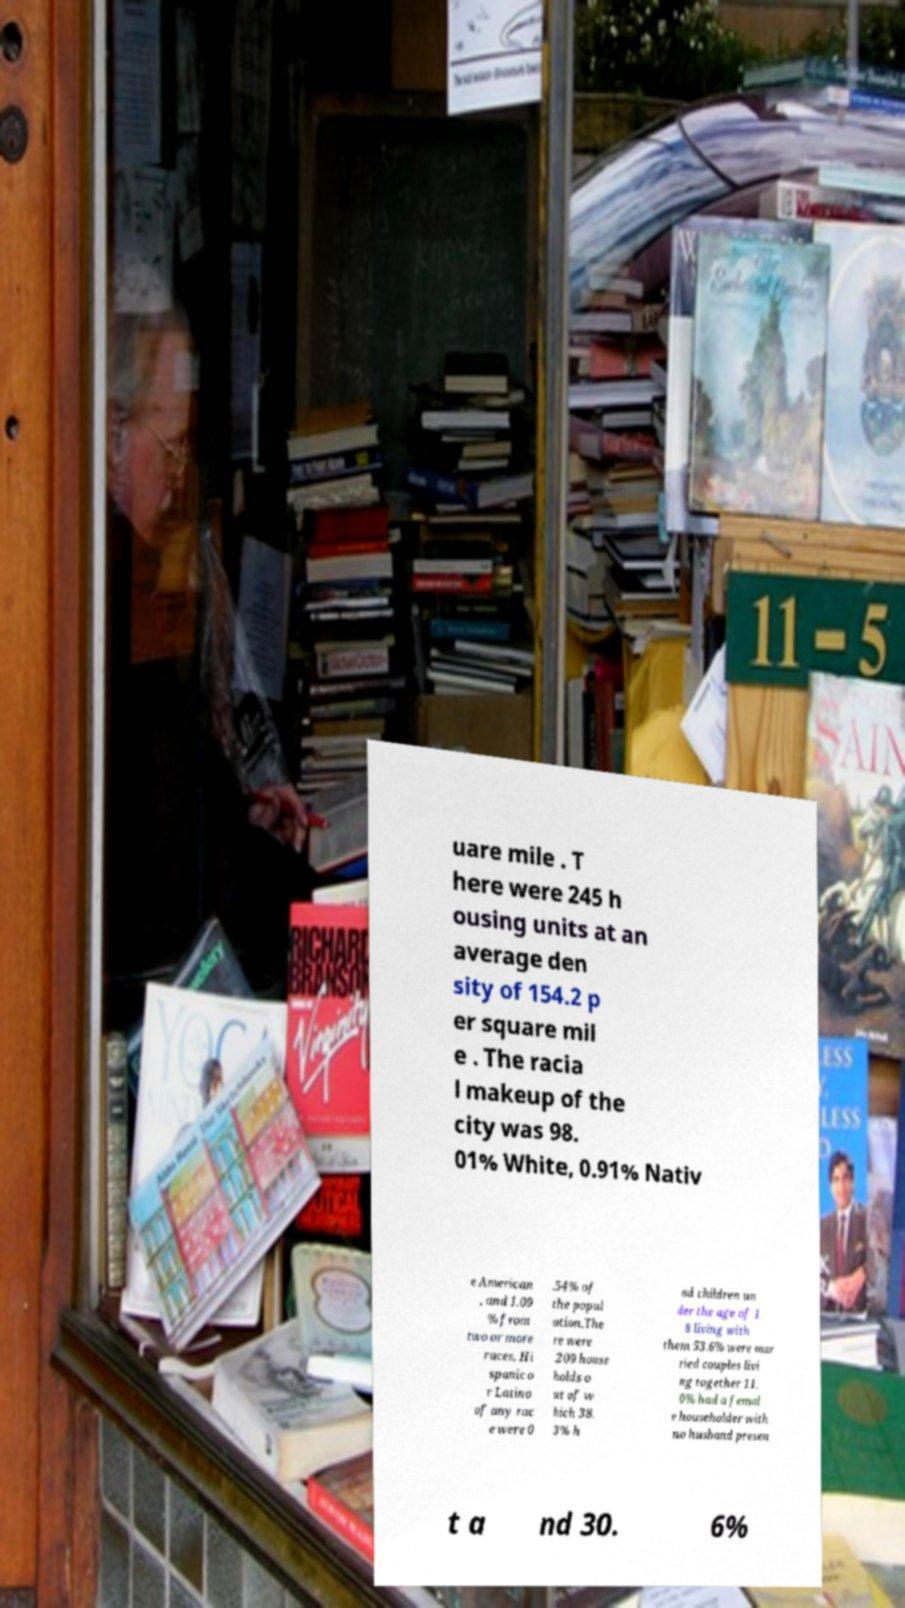Please identify and transcribe the text found in this image. uare mile . T here were 245 h ousing units at an average den sity of 154.2 p er square mil e . The racia l makeup of the city was 98. 01% White, 0.91% Nativ e American , and 1.09 % from two or more races. Hi spanic o r Latino of any rac e were 0 .54% of the popul ation.The re were 209 house holds o ut of w hich 38. 3% h ad children un der the age of 1 8 living with them 53.6% were mar ried couples livi ng together 11. 0% had a femal e householder with no husband presen t a nd 30. 6% 